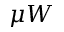Convert formula to latex. <formula><loc_0><loc_0><loc_500><loc_500>\mu W</formula> 